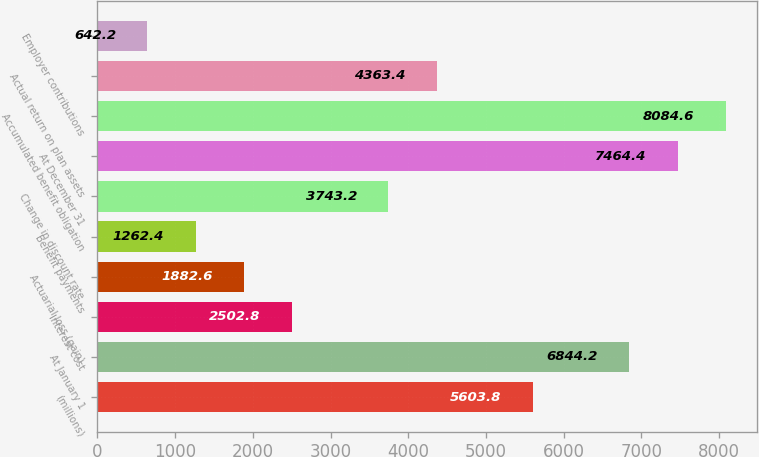Convert chart to OTSL. <chart><loc_0><loc_0><loc_500><loc_500><bar_chart><fcel>(millions)<fcel>At January 1<fcel>Interest cost<fcel>Actuarial loss (gain)<fcel>Benefit payments<fcel>Change in discount rate<fcel>At December 31<fcel>Accumulated benefit obligation<fcel>Actual return on plan assets<fcel>Employer contributions<nl><fcel>5603.8<fcel>6844.2<fcel>2502.8<fcel>1882.6<fcel>1262.4<fcel>3743.2<fcel>7464.4<fcel>8084.6<fcel>4363.4<fcel>642.2<nl></chart> 